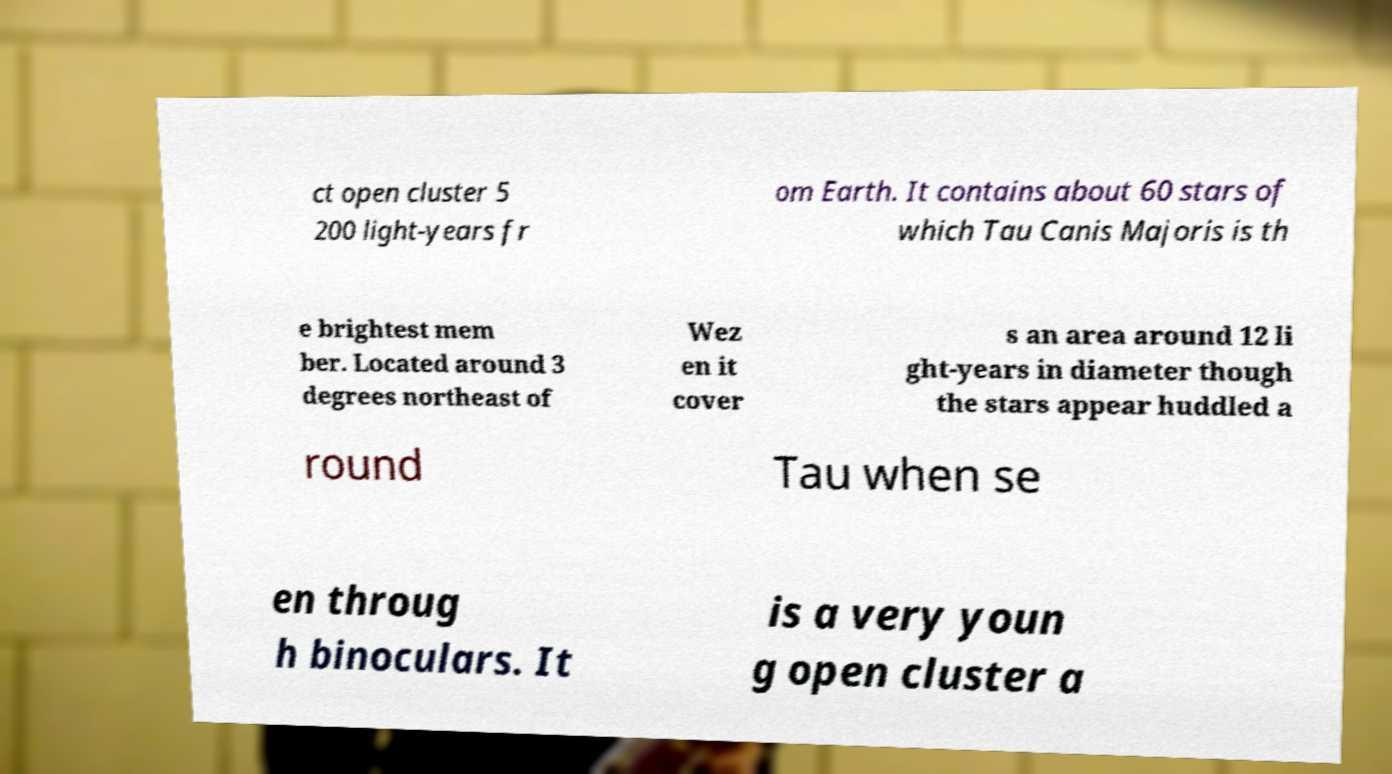Can you accurately transcribe the text from the provided image for me? ct open cluster 5 200 light-years fr om Earth. It contains about 60 stars of which Tau Canis Majoris is th e brightest mem ber. Located around 3 degrees northeast of Wez en it cover s an area around 12 li ght-years in diameter though the stars appear huddled a round Tau when se en throug h binoculars. It is a very youn g open cluster a 